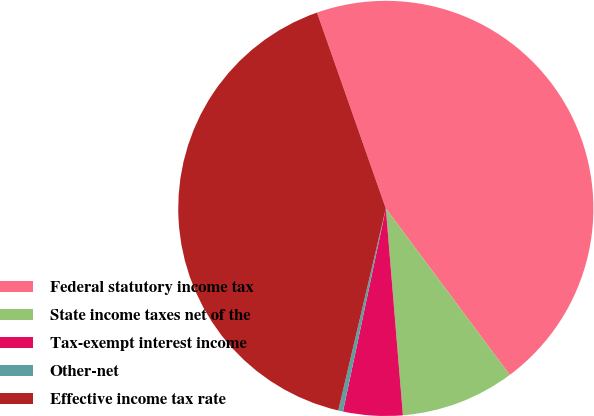<chart> <loc_0><loc_0><loc_500><loc_500><pie_chart><fcel>Federal statutory income tax<fcel>State income taxes net of the<fcel>Tax-exempt interest income<fcel>Other-net<fcel>Effective income tax rate<nl><fcel>45.19%<fcel>8.87%<fcel>4.62%<fcel>0.37%<fcel>40.94%<nl></chart> 